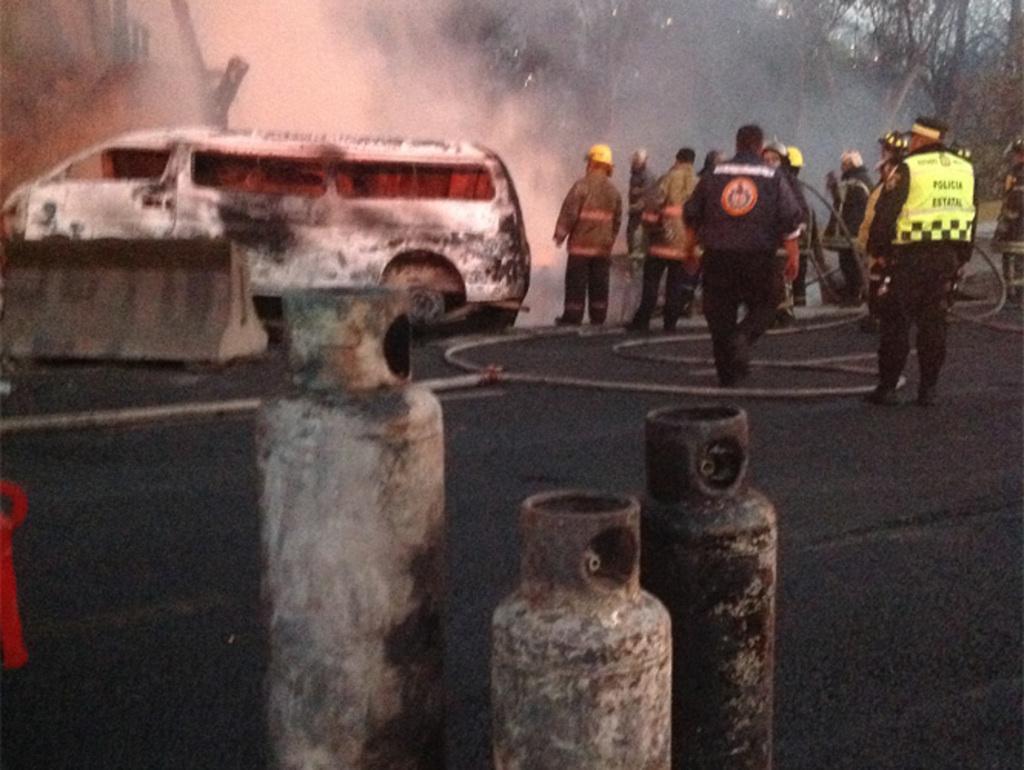Can you describe this image briefly? There are few persons standing in the right corner and there is a pipe in between them and there is a white color vehicle and some other object in the left corner. 